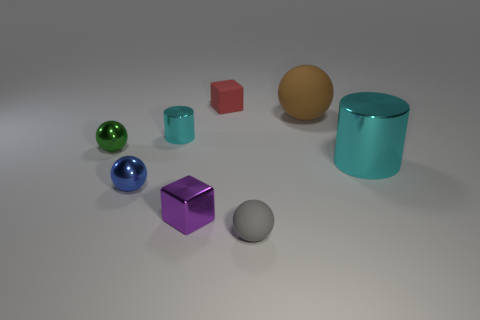Subtract all tiny blue metal spheres. How many spheres are left? 3 Add 1 tiny green metallic things. How many objects exist? 9 Subtract all brown spheres. How many spheres are left? 3 Subtract all cubes. How many objects are left? 6 Subtract all yellow balls. Subtract all gray blocks. How many balls are left? 4 Add 6 small green rubber things. How many small green rubber things exist? 6 Subtract 1 red cubes. How many objects are left? 7 Subtract all small blue shiny objects. Subtract all green metallic balls. How many objects are left? 6 Add 8 blue shiny balls. How many blue shiny balls are left? 9 